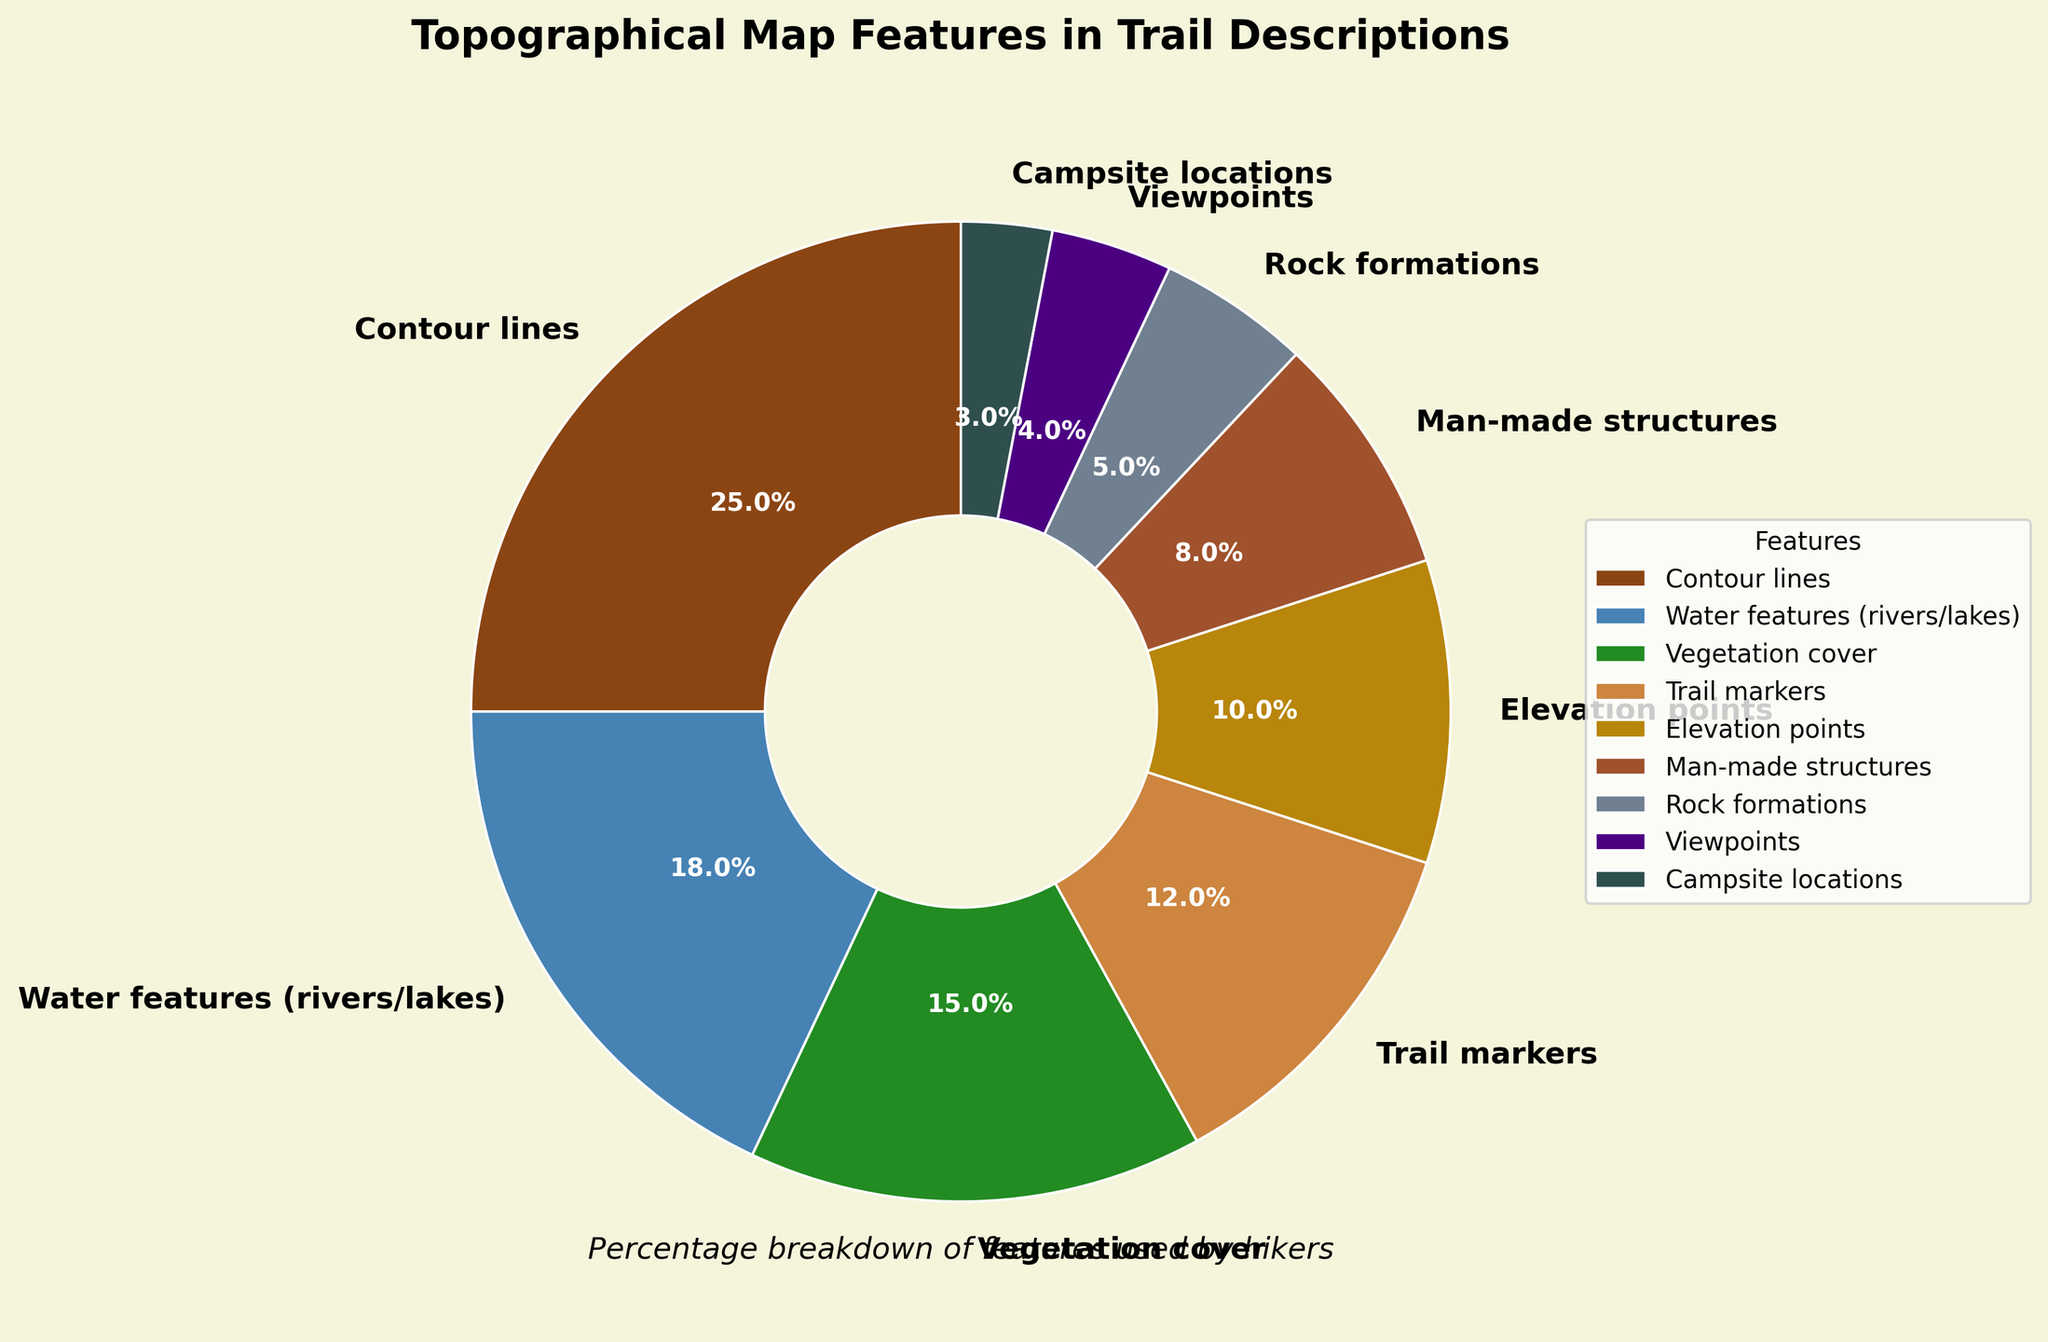Which feature has the largest percentage in the pie chart? Observing the pie chart, the largest wedge belongs to "Contour lines," which is labeled with 25%.
Answer: Contour lines Which feature has the smallest percentage in the pie chart? By examining the smallest wedge in the chart, it's clear that "Campsite locations" has the smallest percentage at 3%.
Answer: Campsite locations How much greater is the percentage of Contour lines than Man-made structures? Contour lines have 25%, and Man-made structures have 8%. The difference is calculated as 25% - 8% = 17%.
Answer: 17% What are the combined percentages of Water features and Vegetation cover? Water features have 18% and Vegetation cover has 15%. Their combined percentage is 18% + 15% = 33%.
Answer: 33% Which feature has a percentage close to half of the percentage of Water features? Water features have 18%, half of which is 9%. The feature with a percentage close to this value is "Elevation points" at 10%.
Answer: Elevation points Which features have percentages that are greater than 10% but less than 20%? Reviewing the wedges, both "Water features (18%)" and "Vegetation cover (15%)" fit this criterion.
Answer: Water features, Vegetation cover What is the average percentage of Trail markers, Man-made structures, and Rock formations? Trail markers (12%), Man-made structures (8%), and Rock formations (5%) have a sum of 12% + 8% + 5% = 25%. Divided by 3, the average is 25% / 3 ≈ 8.33%.
Answer: 8.33% Which feature has a percentage that is almost equal to Viewpoints and Campsite locations combined? Viewpoints have 4%, and Campsite locations have 3%, making a total of 4% + 3% = 7%. "Man-made structures" with 8% is close to this total.
Answer: Man-made structures If you exclude the most prominent feature, what is the total percentage of remaining features? The most prominent feature "Contour lines" with 25% is excluded from the total of 100%, leaving the remaining percentage as 100% - 25% = 75%.
Answer: 75% How does the percentage of Trail markers compare with Rock formations and Viewpoints combined? Trail markers have 12%, while Rock formations (5%) and Viewpoints (4%) combined make 5% + 4% = 9%. Trail markers' percentage (12%) is greater than their combined percentage (9%).
Answer: Trail markers are greater 